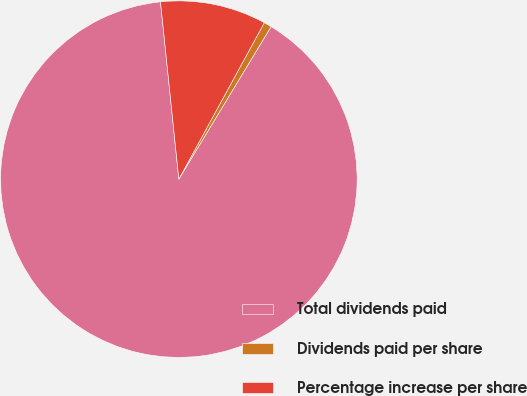Convert chart to OTSL. <chart><loc_0><loc_0><loc_500><loc_500><pie_chart><fcel>Total dividends paid<fcel>Dividends paid per share<fcel>Percentage increase per share<nl><fcel>89.7%<fcel>0.7%<fcel>9.6%<nl></chart> 